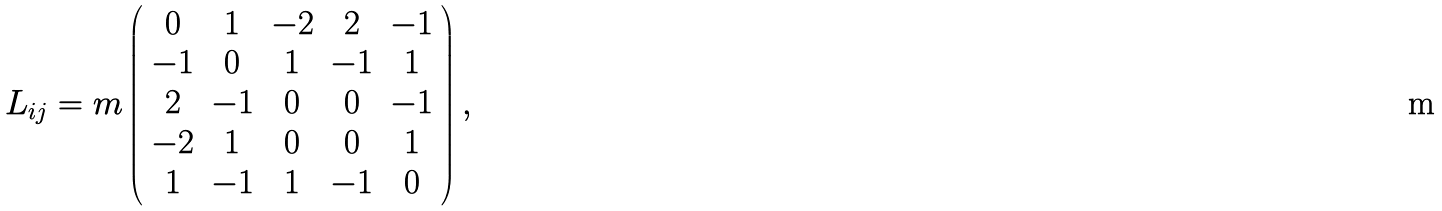Convert formula to latex. <formula><loc_0><loc_0><loc_500><loc_500>L _ { i j } = m \left ( \begin{array} { c c c c c } 0 & 1 & - 2 & 2 & - 1 \\ - 1 & 0 & 1 & - 1 & 1 \\ 2 & - 1 & 0 & 0 & - 1 \\ - 2 & 1 & 0 & 0 & 1 \\ 1 & - 1 & 1 & - 1 & 0 \end{array} \right ) ,</formula> 